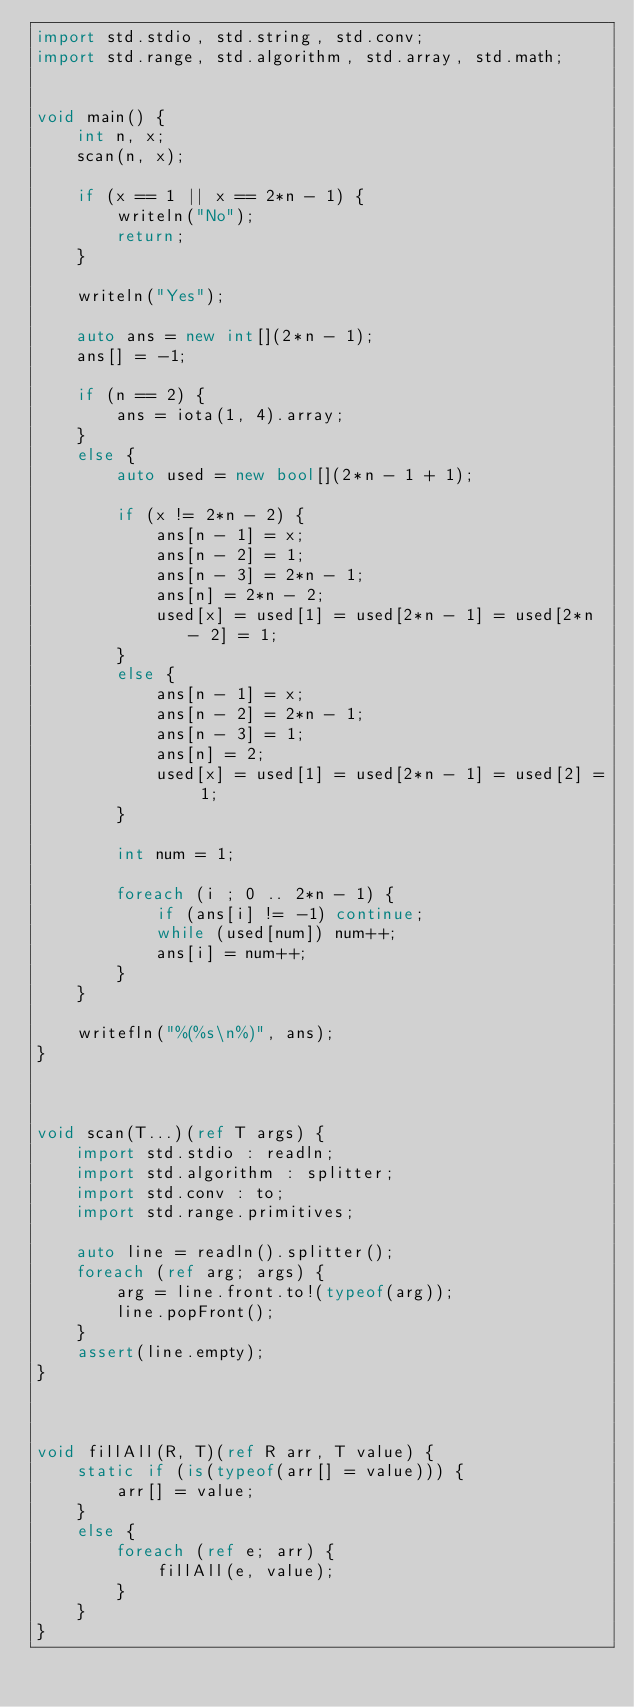<code> <loc_0><loc_0><loc_500><loc_500><_D_>import std.stdio, std.string, std.conv;
import std.range, std.algorithm, std.array, std.math;


void main() {
    int n, x;
    scan(n, x);

    if (x == 1 || x == 2*n - 1) {
        writeln("No");
        return;
    }

    writeln("Yes");

    auto ans = new int[](2*n - 1);
    ans[] = -1;

    if (n == 2) {
        ans = iota(1, 4).array;
    }
    else {
        auto used = new bool[](2*n - 1 + 1);

        if (x != 2*n - 2) {
            ans[n - 1] = x;
            ans[n - 2] = 1;
            ans[n - 3] = 2*n - 1;
            ans[n] = 2*n - 2;
            used[x] = used[1] = used[2*n - 1] = used[2*n - 2] = 1;
        }
        else {
            ans[n - 1] = x;
            ans[n - 2] = 2*n - 1;
            ans[n - 3] = 1;
            ans[n] = 2;
            used[x] = used[1] = used[2*n - 1] = used[2] = 1;
        }

        int num = 1;

        foreach (i ; 0 .. 2*n - 1) {
            if (ans[i] != -1) continue;
            while (used[num]) num++;
            ans[i] = num++;
        }
    }

    writefln("%(%s\n%)", ans);
}



void scan(T...)(ref T args) {
    import std.stdio : readln;
    import std.algorithm : splitter;
    import std.conv : to;
    import std.range.primitives;

    auto line = readln().splitter();
    foreach (ref arg; args) {
        arg = line.front.to!(typeof(arg));
        line.popFront();
    }
    assert(line.empty);
}



void fillAll(R, T)(ref R arr, T value) {
    static if (is(typeof(arr[] = value))) {
        arr[] = value;
    }
    else {
        foreach (ref e; arr) {
            fillAll(e, value);
        }
    }
}
</code> 